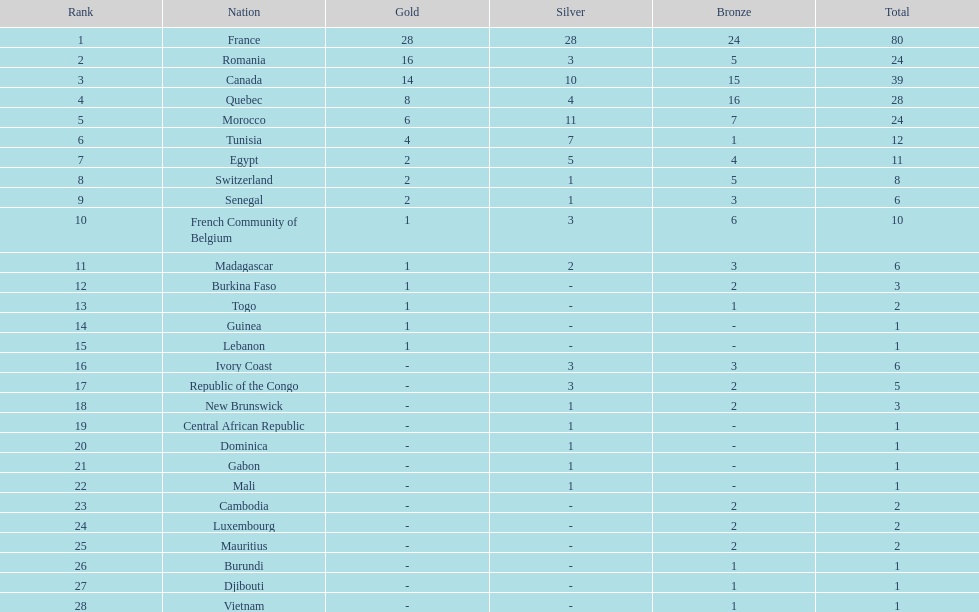What is the disparity between silver medals of france and egypt? 23. 